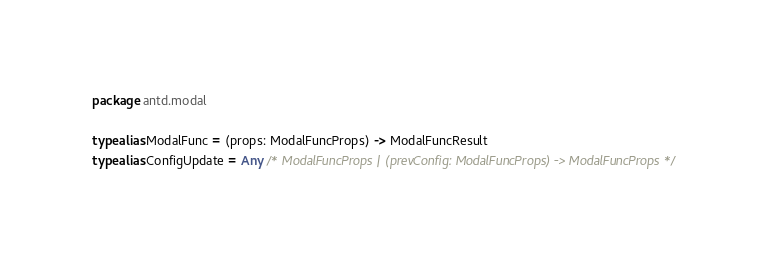<code> <loc_0><loc_0><loc_500><loc_500><_Kotlin_>package antd.modal

typealias ModalFunc = (props: ModalFuncProps) -> ModalFuncResult
typealias ConfigUpdate = Any /* ModalFuncProps | (prevConfig: ModalFuncProps) -> ModalFuncProps */
</code> 